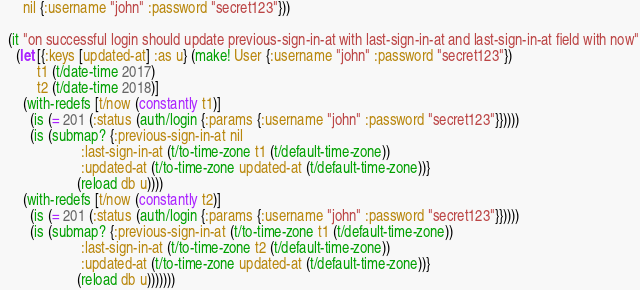<code> <loc_0><loc_0><loc_500><loc_500><_Clojure_>      nil {:username "john" :password "secret123"}))

  (it "on successful login should update previous-sign-in-at with last-sign-in-at and last-sign-in-at field with now"
    (let [{:keys [updated-at] :as u} (make! User {:username "john" :password "secret123"})
          t1 (t/date-time 2017)
          t2 (t/date-time 2018)]
      (with-redefs [t/now (constantly t1)]
        (is (= 201 (:status (auth/login {:params {:username "john" :password "secret123"}}))))
        (is (submap? {:previous-sign-in-at nil
                      :last-sign-in-at (t/to-time-zone t1 (t/default-time-zone))
                      :updated-at (t/to-time-zone updated-at (t/default-time-zone))}
                     (reload db u))))
      (with-redefs [t/now (constantly t2)]
        (is (= 201 (:status (auth/login {:params {:username "john" :password "secret123"}}))))
        (is (submap? {:previous-sign-in-at (t/to-time-zone t1 (t/default-time-zone))
                      :last-sign-in-at (t/to-time-zone t2 (t/default-time-zone))
                      :updated-at (t/to-time-zone updated-at (t/default-time-zone))}
                     (reload db u)))))))
</code> 